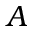<formula> <loc_0><loc_0><loc_500><loc_500>A</formula> 